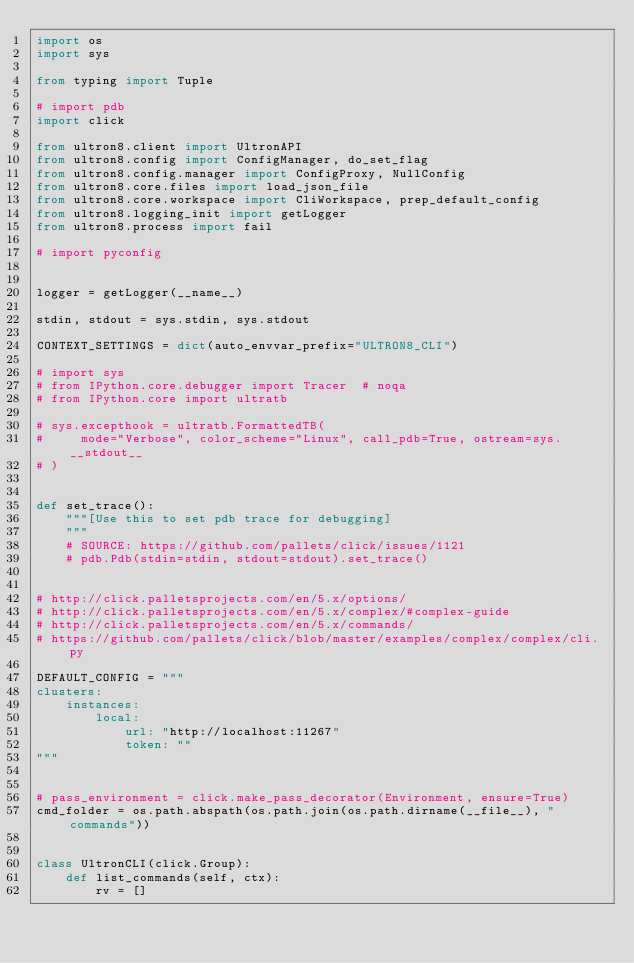<code> <loc_0><loc_0><loc_500><loc_500><_Python_>import os
import sys

from typing import Tuple

# import pdb
import click

from ultron8.client import UltronAPI
from ultron8.config import ConfigManager, do_set_flag
from ultron8.config.manager import ConfigProxy, NullConfig
from ultron8.core.files import load_json_file
from ultron8.core.workspace import CliWorkspace, prep_default_config
from ultron8.logging_init import getLogger
from ultron8.process import fail

# import pyconfig


logger = getLogger(__name__)

stdin, stdout = sys.stdin, sys.stdout

CONTEXT_SETTINGS = dict(auto_envvar_prefix="ULTRON8_CLI")

# import sys
# from IPython.core.debugger import Tracer  # noqa
# from IPython.core import ultratb

# sys.excepthook = ultratb.FormattedTB(
#     mode="Verbose", color_scheme="Linux", call_pdb=True, ostream=sys.__stdout__
# )


def set_trace():
    """[Use this to set pdb trace for debugging]
    """
    # SOURCE: https://github.com/pallets/click/issues/1121
    # pdb.Pdb(stdin=stdin, stdout=stdout).set_trace()


# http://click.palletsprojects.com/en/5.x/options/
# http://click.palletsprojects.com/en/5.x/complex/#complex-guide
# http://click.palletsprojects.com/en/5.x/commands/
# https://github.com/pallets/click/blob/master/examples/complex/complex/cli.py

DEFAULT_CONFIG = """
clusters:
    instances:
        local:
            url: "http://localhost:11267"
            token: ""
"""


# pass_environment = click.make_pass_decorator(Environment, ensure=True)
cmd_folder = os.path.abspath(os.path.join(os.path.dirname(__file__), "commands"))


class UltronCLI(click.Group):
    def list_commands(self, ctx):
        rv = []</code> 